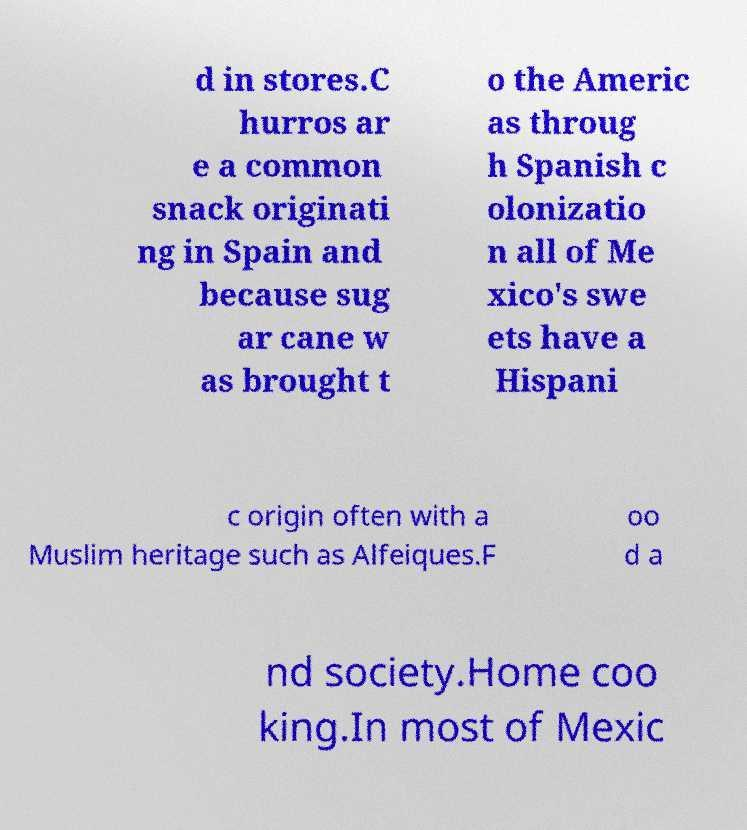Can you read and provide the text displayed in the image?This photo seems to have some interesting text. Can you extract and type it out for me? d in stores.C hurros ar e a common snack originati ng in Spain and because sug ar cane w as brought t o the Americ as throug h Spanish c olonizatio n all of Me xico's swe ets have a Hispani c origin often with a Muslim heritage such as Alfeiques.F oo d a nd society.Home coo king.In most of Mexic 